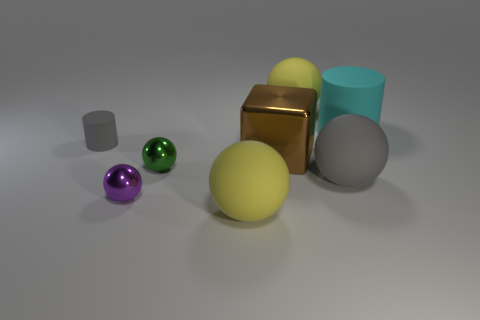There is a yellow matte object that is behind the cyan matte thing; is it the same size as the metallic cube?
Your answer should be compact. Yes. How many objects are tiny green shiny balls that are right of the small rubber object or yellow matte things on the right side of the large brown thing?
Your answer should be compact. 2. Does the cylinder that is in front of the big cyan matte cylinder have the same color as the block?
Provide a short and direct response. No. How many matte things are either green spheres or large green cylinders?
Make the answer very short. 0. What is the shape of the small green object?
Offer a terse response. Sphere. Is there any other thing that has the same material as the purple sphere?
Your response must be concise. Yes. Is the material of the large brown thing the same as the small cylinder?
Provide a succinct answer. No. There is a large sphere that is on the left side of the ball that is behind the big rubber cylinder; is there a gray thing to the left of it?
Offer a very short reply. Yes. What number of other objects are the same shape as the purple metallic thing?
Provide a succinct answer. 4. What shape is the matte thing that is both left of the large rubber cylinder and behind the small matte cylinder?
Make the answer very short. Sphere. 